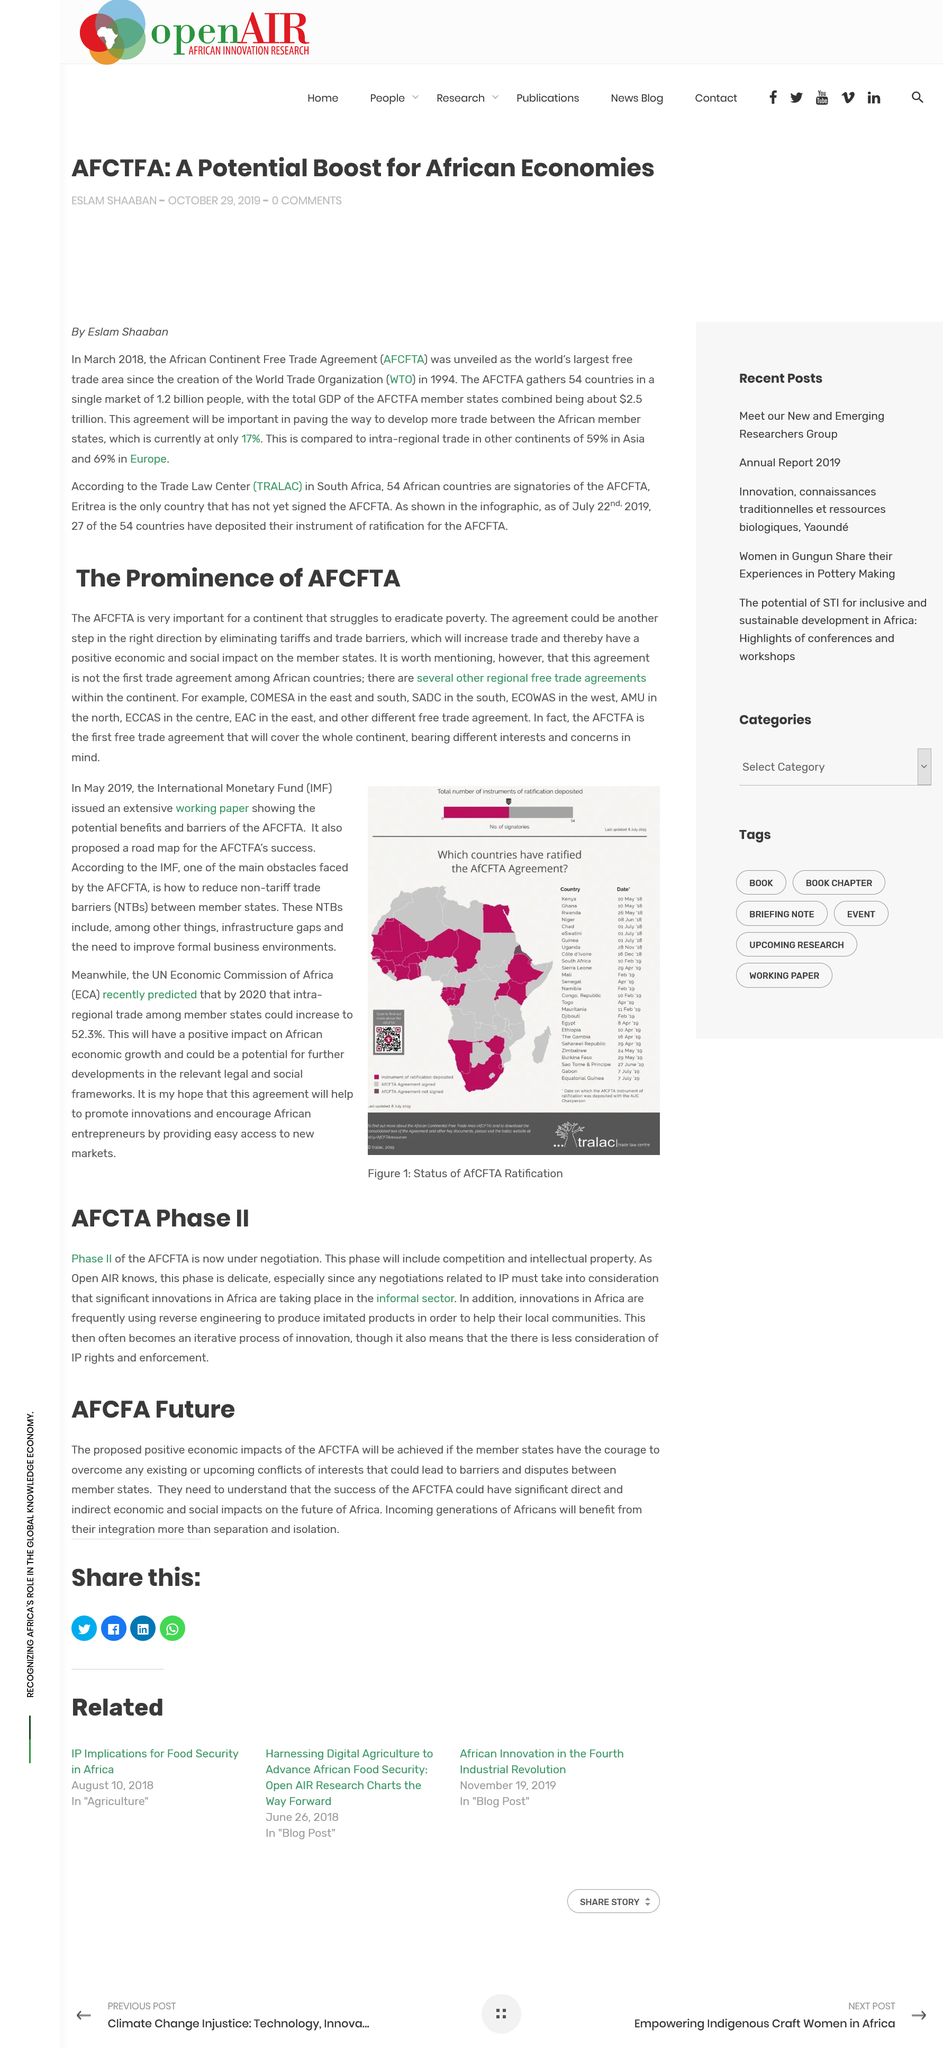Indicate a few pertinent items in this graphic. COMESA is located in the East and South regions. Significant innovations are occurring in Africa, particularly in countries such as South Africa and Kenya. The existence or potential for conflicting interests among member states may result in disputes and obstacles to cooperation. AFCTFA proposes that if member states have the courage to overcome conflicts of interests with other member states, positive economic impact on Africa can be achieved. The success of AFCTFA would have a profound impact on the future of Africa, with numerous direct and indirect economic and social benefits, and would ensure the integration of the AFCTFA would benefit generations to come. 